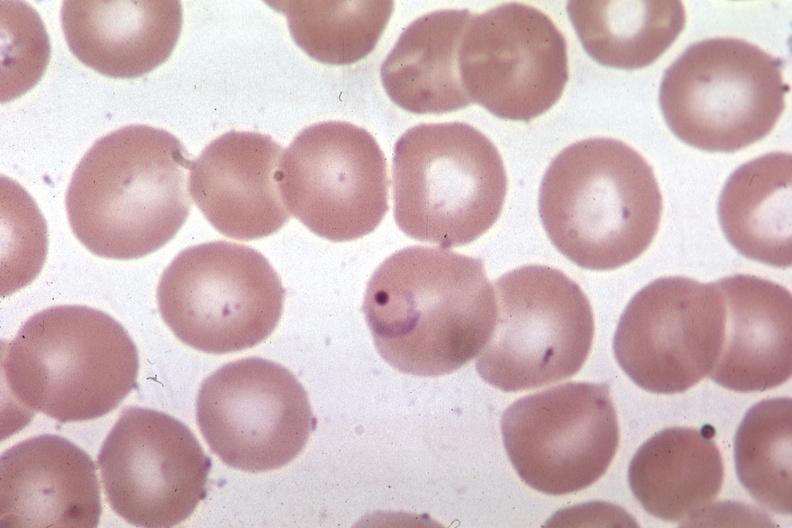what is present?
Answer the question using a single word or phrase. Blood 